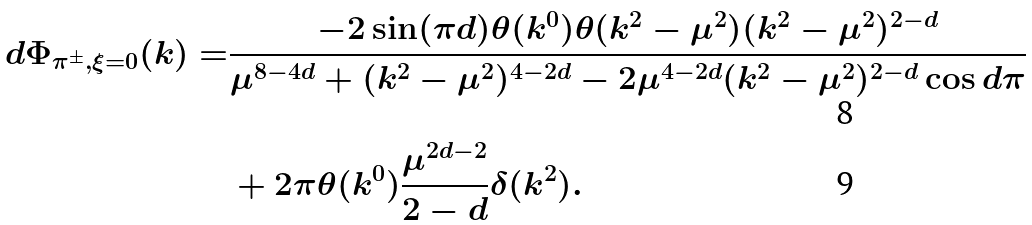<formula> <loc_0><loc_0><loc_500><loc_500>d \Phi _ { \pi ^ { \pm } , \xi = 0 } ( k ) = & \frac { - 2 \sin ( \pi d ) \theta ( k ^ { 0 } ) \theta ( k ^ { 2 } - \mu ^ { 2 } ) ( k ^ { 2 } - \mu ^ { 2 } ) ^ { 2 - d } } { \mu ^ { 8 - 4 d } + ( k ^ { 2 } - \mu ^ { 2 } ) ^ { 4 - 2 d } - 2 \mu ^ { 4 - 2 d } ( k ^ { 2 } - \mu ^ { 2 } ) ^ { 2 - d } \cos { d \pi } } \\ & + 2 \pi \theta ( k ^ { 0 } ) \frac { \mu ^ { 2 d - 2 } } { 2 - d } \delta ( k ^ { 2 } ) .</formula> 